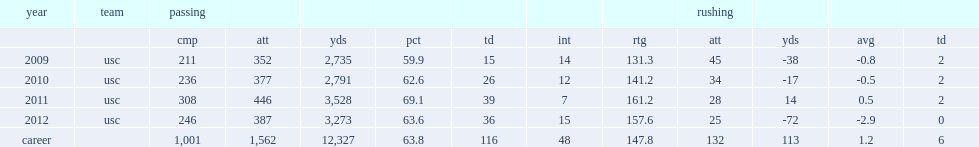What was the touchdown-to-interception ratio in 2011? 39.0 7.0. 